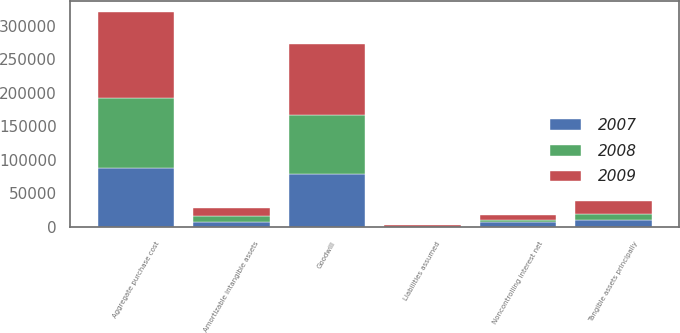<chart> <loc_0><loc_0><loc_500><loc_500><stacked_bar_chart><ecel><fcel>Tangible assets principally<fcel>Amortizable intangible assets<fcel>Goodwill<fcel>Noncontrolling interest net<fcel>Liabilities assumed<fcel>Aggregate purchase cost<nl><fcel>2007<fcel>11140<fcel>6703<fcel>78199<fcel>7567<fcel>520<fcel>87955<nl><fcel>2008<fcel>7972<fcel>9988<fcel>89234<fcel>2732<fcel>217<fcel>104245<nl><fcel>2009<fcel>20085<fcel>12271<fcel>105609<fcel>7987<fcel>1689<fcel>128289<nl></chart> 